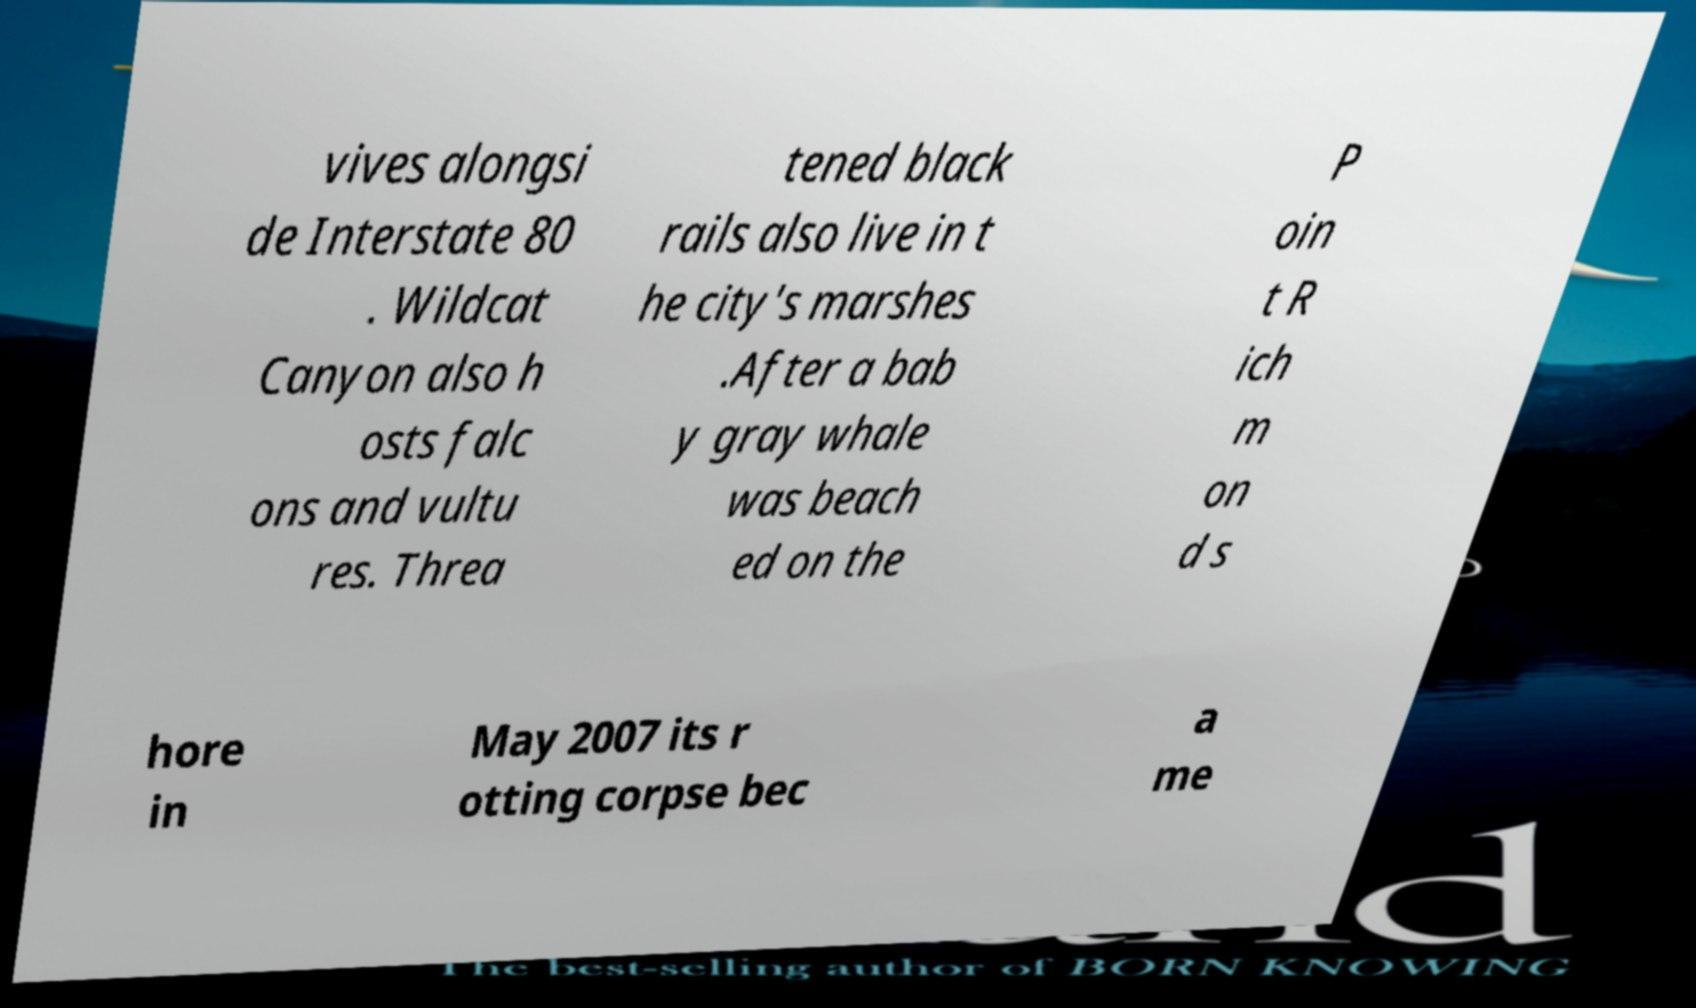Please identify and transcribe the text found in this image. vives alongsi de Interstate 80 . Wildcat Canyon also h osts falc ons and vultu res. Threa tened black rails also live in t he city's marshes .After a bab y gray whale was beach ed on the P oin t R ich m on d s hore in May 2007 its r otting corpse bec a me 